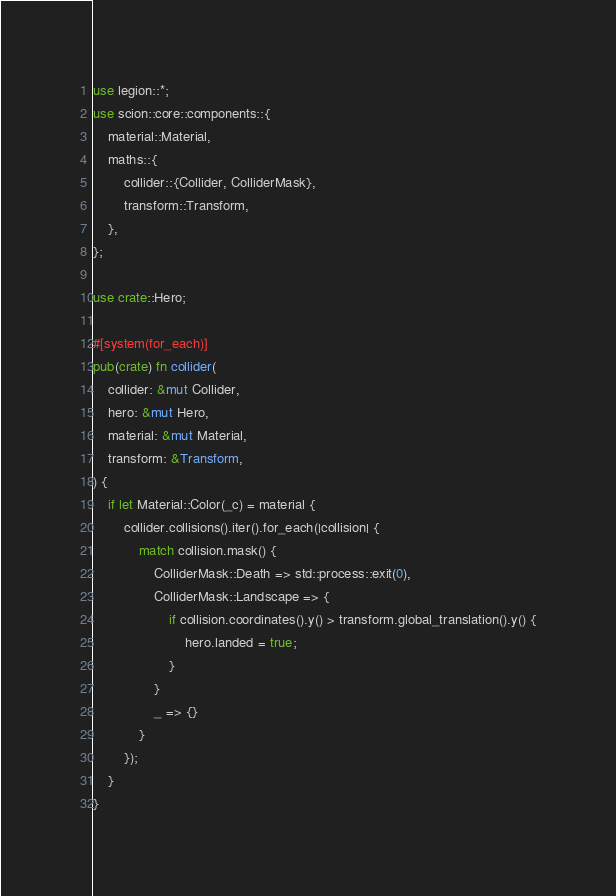Convert code to text. <code><loc_0><loc_0><loc_500><loc_500><_Rust_>use legion::*;
use scion::core::components::{
    material::Material,
    maths::{
        collider::{Collider, ColliderMask},
        transform::Transform,
    },
};

use crate::Hero;

#[system(for_each)]
pub(crate) fn collider(
    collider: &mut Collider,
    hero: &mut Hero,
    material: &mut Material,
    transform: &Transform,
) {
    if let Material::Color(_c) = material {
        collider.collisions().iter().for_each(|collision| {
            match collision.mask() {
                ColliderMask::Death => std::process::exit(0),
                ColliderMask::Landscape => {
                    if collision.coordinates().y() > transform.global_translation().y() {
                        hero.landed = true;
                    }
                }
                _ => {}
            }
        });
    }
}
</code> 